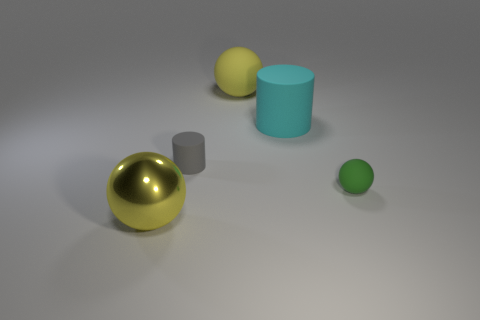Is there a yellow metallic thing of the same shape as the tiny gray matte object?
Make the answer very short. No. The small gray thing is what shape?
Make the answer very short. Cylinder. What material is the yellow object behind the ball that is left of the yellow ball right of the gray matte cylinder?
Ensure brevity in your answer.  Rubber. Is the number of big cyan cylinders that are in front of the green matte thing greater than the number of metal things?
Provide a short and direct response. No. What is the material of the green sphere that is the same size as the gray matte cylinder?
Ensure brevity in your answer.  Rubber. Is there a brown rubber cylinder that has the same size as the gray thing?
Offer a very short reply. No. There is a cylinder that is left of the large cyan matte cylinder; what size is it?
Give a very brief answer. Small. The metallic sphere has what size?
Your answer should be compact. Large. What number of balls are either yellow shiny objects or tiny green rubber things?
Give a very brief answer. 2. The gray object that is the same material as the cyan cylinder is what size?
Your answer should be very brief. Small. 